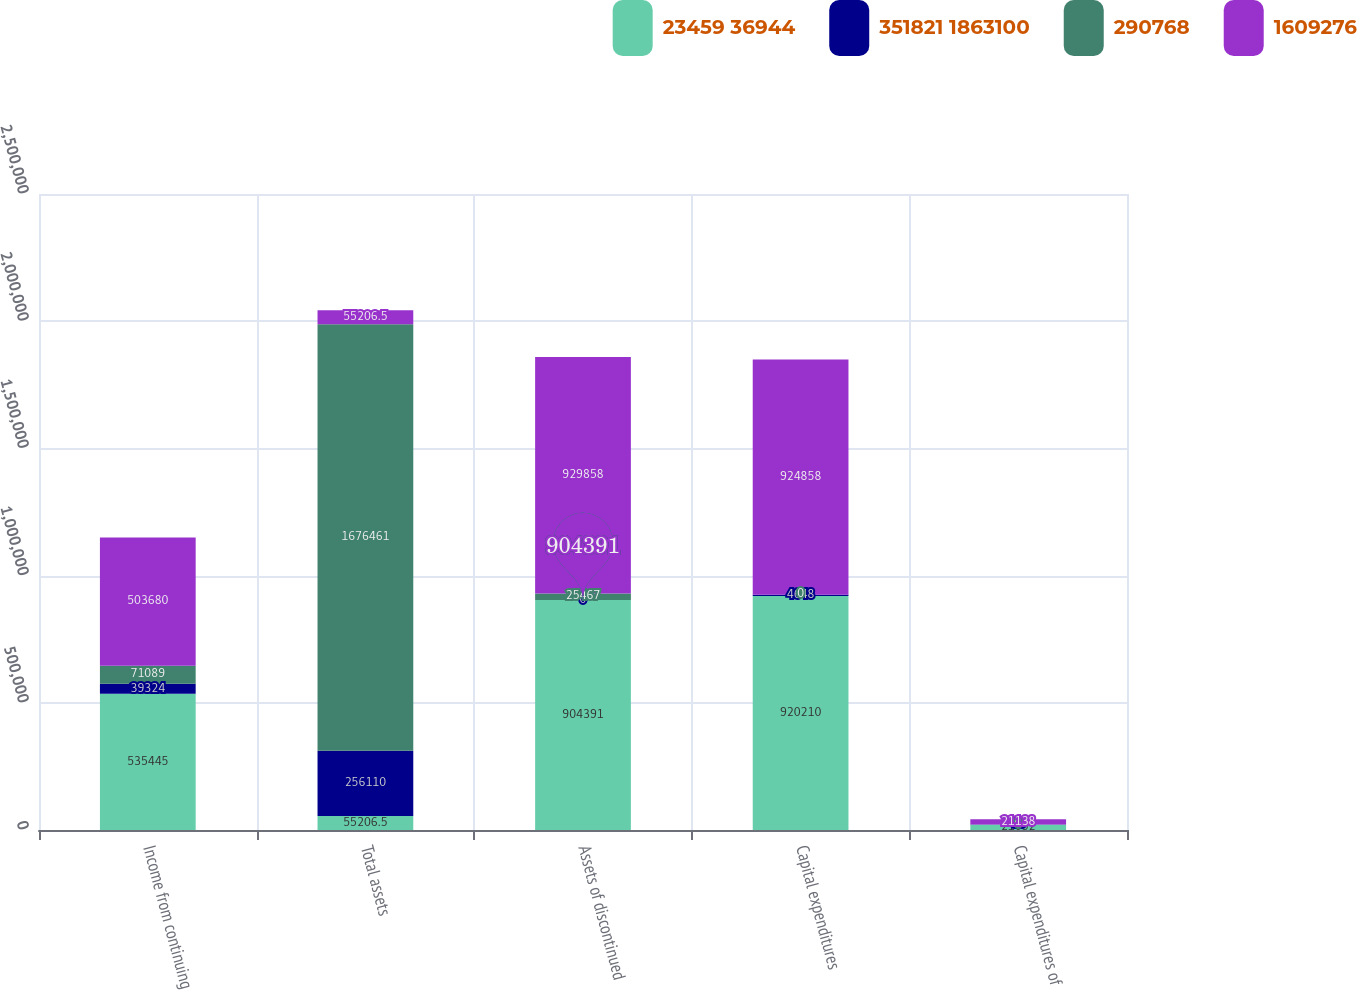Convert chart to OTSL. <chart><loc_0><loc_0><loc_500><loc_500><stacked_bar_chart><ecel><fcel>Income from continuing<fcel>Total assets<fcel>Assets of discontinued<fcel>Capital expenditures<fcel>Capital expenditures of<nl><fcel>23459 36944<fcel>535445<fcel>55206.5<fcel>904391<fcel>920210<fcel>21052<nl><fcel>351821 1863100<fcel>39324<fcel>256110<fcel>0<fcel>4648<fcel>86<nl><fcel>290768<fcel>71089<fcel>1.67646e+06<fcel>25467<fcel>0<fcel>0<nl><fcel>1609276<fcel>503680<fcel>55206.5<fcel>929858<fcel>924858<fcel>21138<nl></chart> 